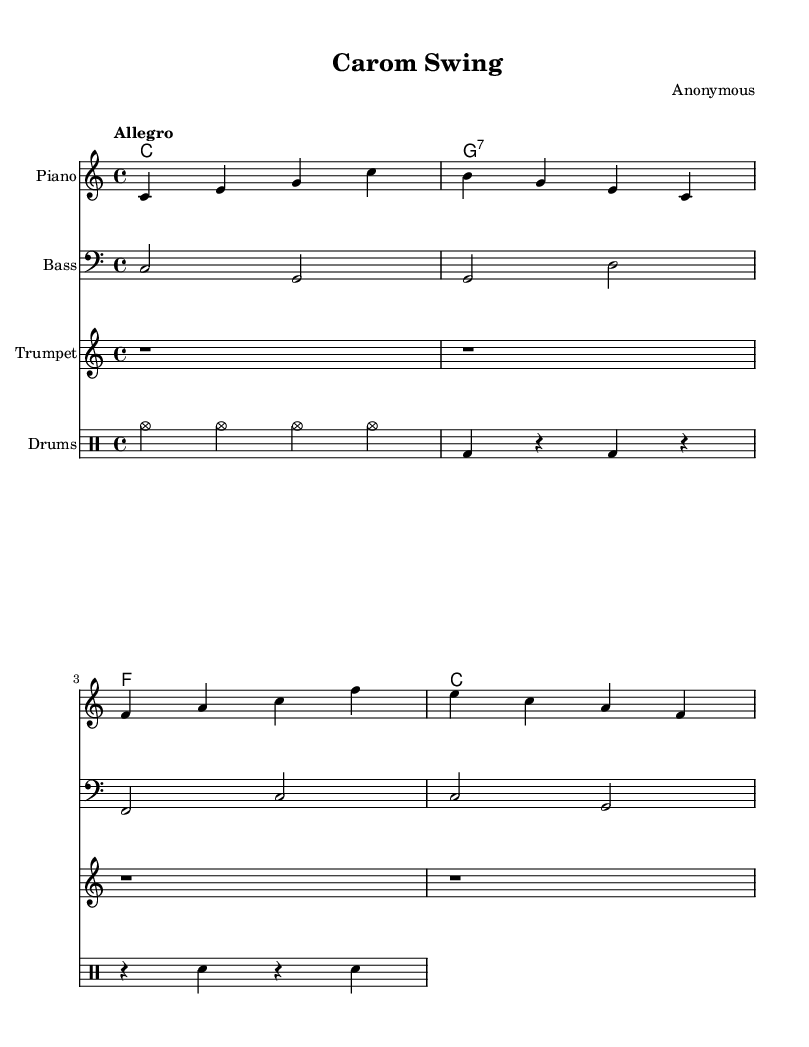What is the key signature of this music? The key signature is indicated at the beginning of the staff, showing no sharps or flats, which corresponds to C major.
Answer: C major What is the time signature of this piece? The time signature is located at the beginning of the music, represented as a fraction; in this case, 4 over 4 indicates four beats in a measure with a quarter note receiving one beat.
Answer: 4/4 What is the tempo marking for this piece? The tempo marking, located above the staff, instructs the performer to play at a lively pace, which is indicated by the word "Allegro."
Answer: Allegro How many measures does the piano part have? By counting the individual groups of notes in the piano part written in the sheet, we find there are four measures present.
Answer: 4 Which instrument has no notes written in this section? The trumpet part is represented by rest symbols (r), showing that no notes are being played through the entire section presented, indicating silence.
Answer: Trumpet What chord is specified in the second measure? The chord representation located above the bass staff indicates that the chord being played in the second measure is a G7 chord, which consists of the notes G, B, D, and F.
Answer: G:7 What is the rhythmic pattern in the drum part? The drum part includes a pattern consisting of cymbals (cymc), bass drum (bd), and snare (sn) with a combination of quarter notes and rests, emphasizing various beats throughout the measure.
Answer: Cymbals and bass drum pattern 